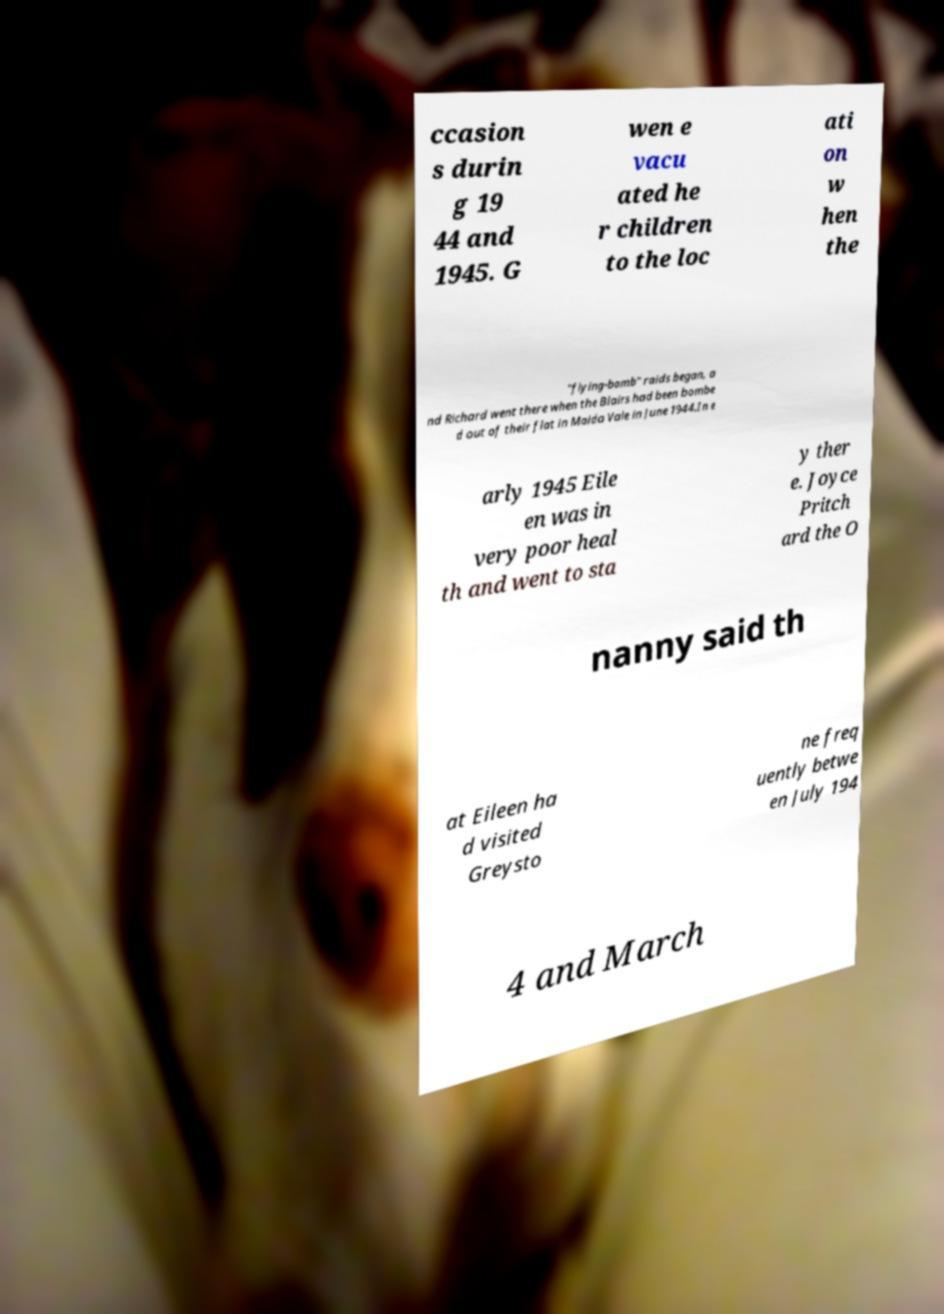Can you read and provide the text displayed in the image?This photo seems to have some interesting text. Can you extract and type it out for me? ccasion s durin g 19 44 and 1945. G wen e vacu ated he r children to the loc ati on w hen the "flying-bomb" raids began, a nd Richard went there when the Blairs had been bombe d out of their flat in Maida Vale in June 1944.In e arly 1945 Eile en was in very poor heal th and went to sta y ther e. Joyce Pritch ard the O nanny said th at Eileen ha d visited Greysto ne freq uently betwe en July 194 4 and March 